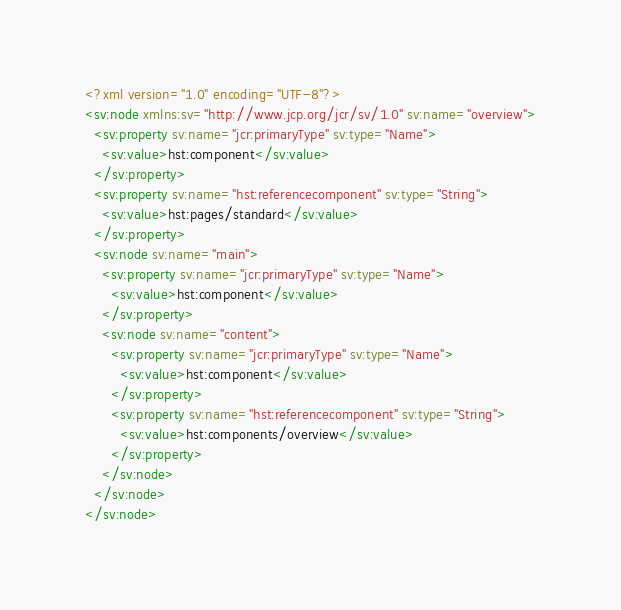<code> <loc_0><loc_0><loc_500><loc_500><_XML_><?xml version="1.0" encoding="UTF-8"?>
<sv:node xmlns:sv="http://www.jcp.org/jcr/sv/1.0" sv:name="overview">
  <sv:property sv:name="jcr:primaryType" sv:type="Name">
    <sv:value>hst:component</sv:value>
  </sv:property>
  <sv:property sv:name="hst:referencecomponent" sv:type="String">
    <sv:value>hst:pages/standard</sv:value>
  </sv:property>
  <sv:node sv:name="main">
    <sv:property sv:name="jcr:primaryType" sv:type="Name">
      <sv:value>hst:component</sv:value>
    </sv:property>
    <sv:node sv:name="content">
      <sv:property sv:name="jcr:primaryType" sv:type="Name">
        <sv:value>hst:component</sv:value>
      </sv:property>
      <sv:property sv:name="hst:referencecomponent" sv:type="String">
        <sv:value>hst:components/overview</sv:value>
      </sv:property>
    </sv:node>
  </sv:node>
</sv:node></code> 